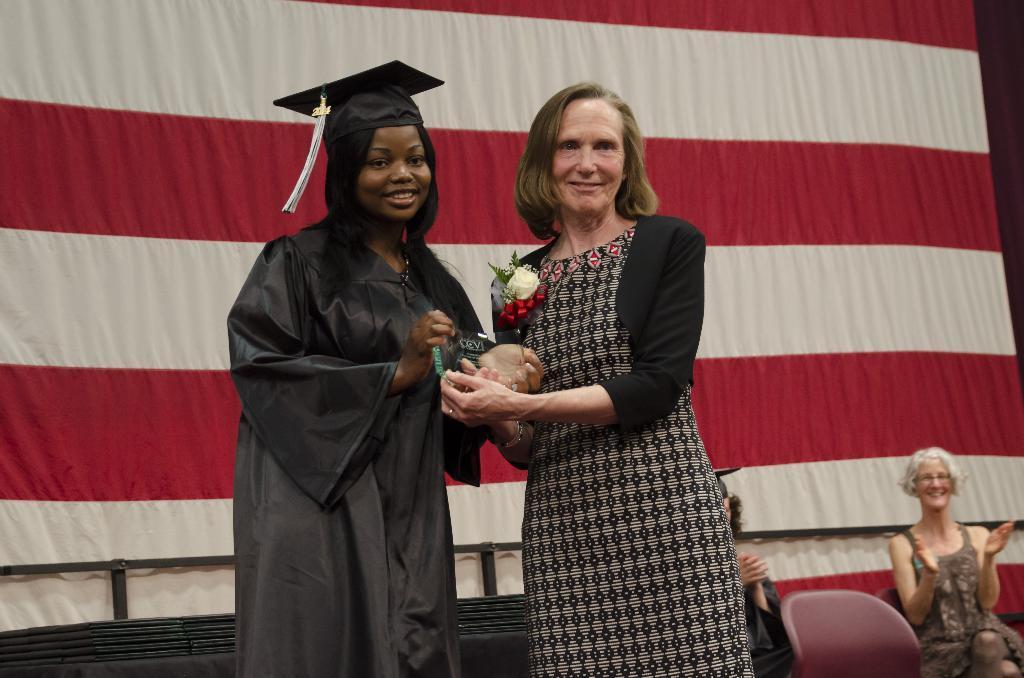Could you give a brief overview of what you see in this image? In this picture we can see a cap, flower, leaves and two women holding a shield with their hands and standing and smiling and at the back of them we can see two people sitting on chairs, curtain and some objects. 